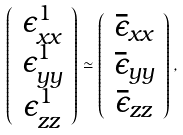<formula> <loc_0><loc_0><loc_500><loc_500>\left ( \begin{array} { c } \epsilon ^ { 1 } _ { x x } \\ \epsilon ^ { 1 } _ { y y } \\ \epsilon ^ { 1 } _ { z z } \\ \end{array} \right ) \simeq \left ( \begin{array} { c } \bar { \epsilon } _ { x x } \\ \bar { \epsilon } _ { y y } \\ \bar { \epsilon } _ { z z } \\ \end{array} \right ) ,</formula> 